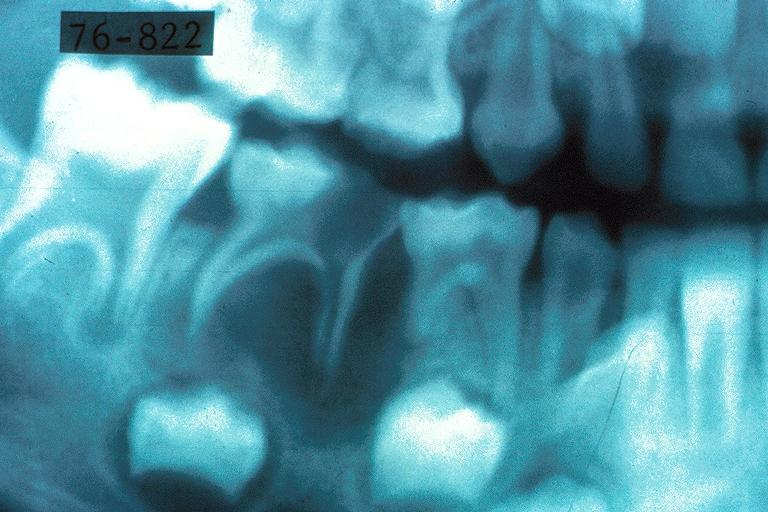does history show turners tooth?
Answer the question using a single word or phrase. No 